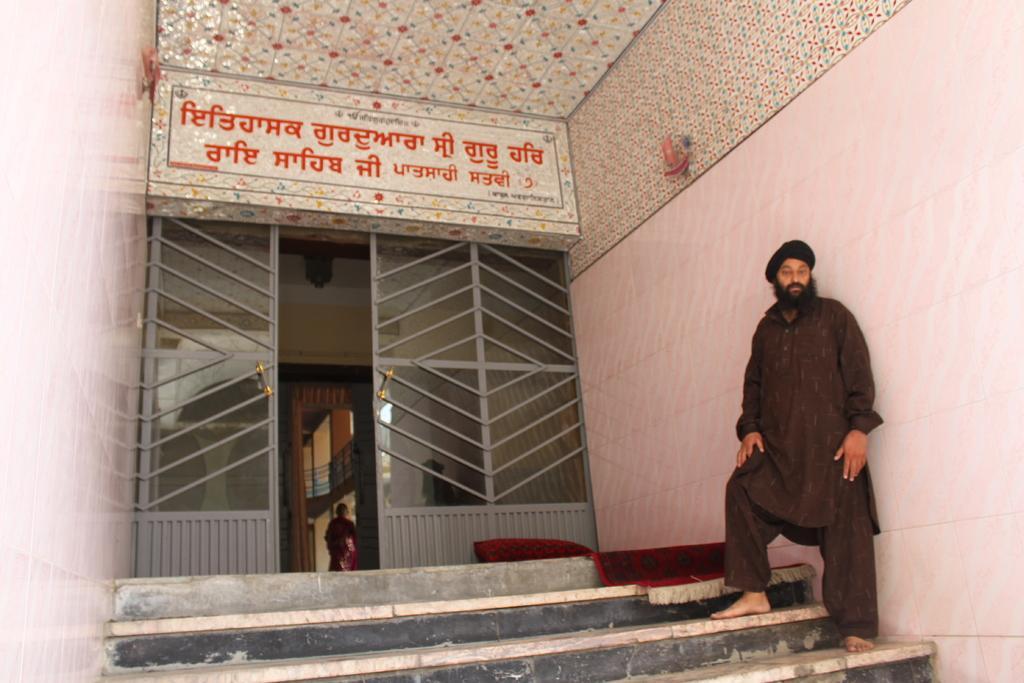Describe this image in one or two sentences. In this picture we can see one person is standing on the stairs in front of the house. 